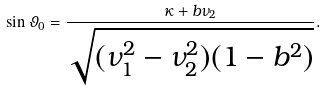Convert formula to latex. <formula><loc_0><loc_0><loc_500><loc_500>\sin \vartheta _ { 0 } = \frac { \kappa + b \nu _ { 2 } } { \sqrt { ( \nu _ { 1 } ^ { 2 } - \nu _ { 2 } ^ { 2 } ) ( 1 - b ^ { 2 } ) } } .</formula> 